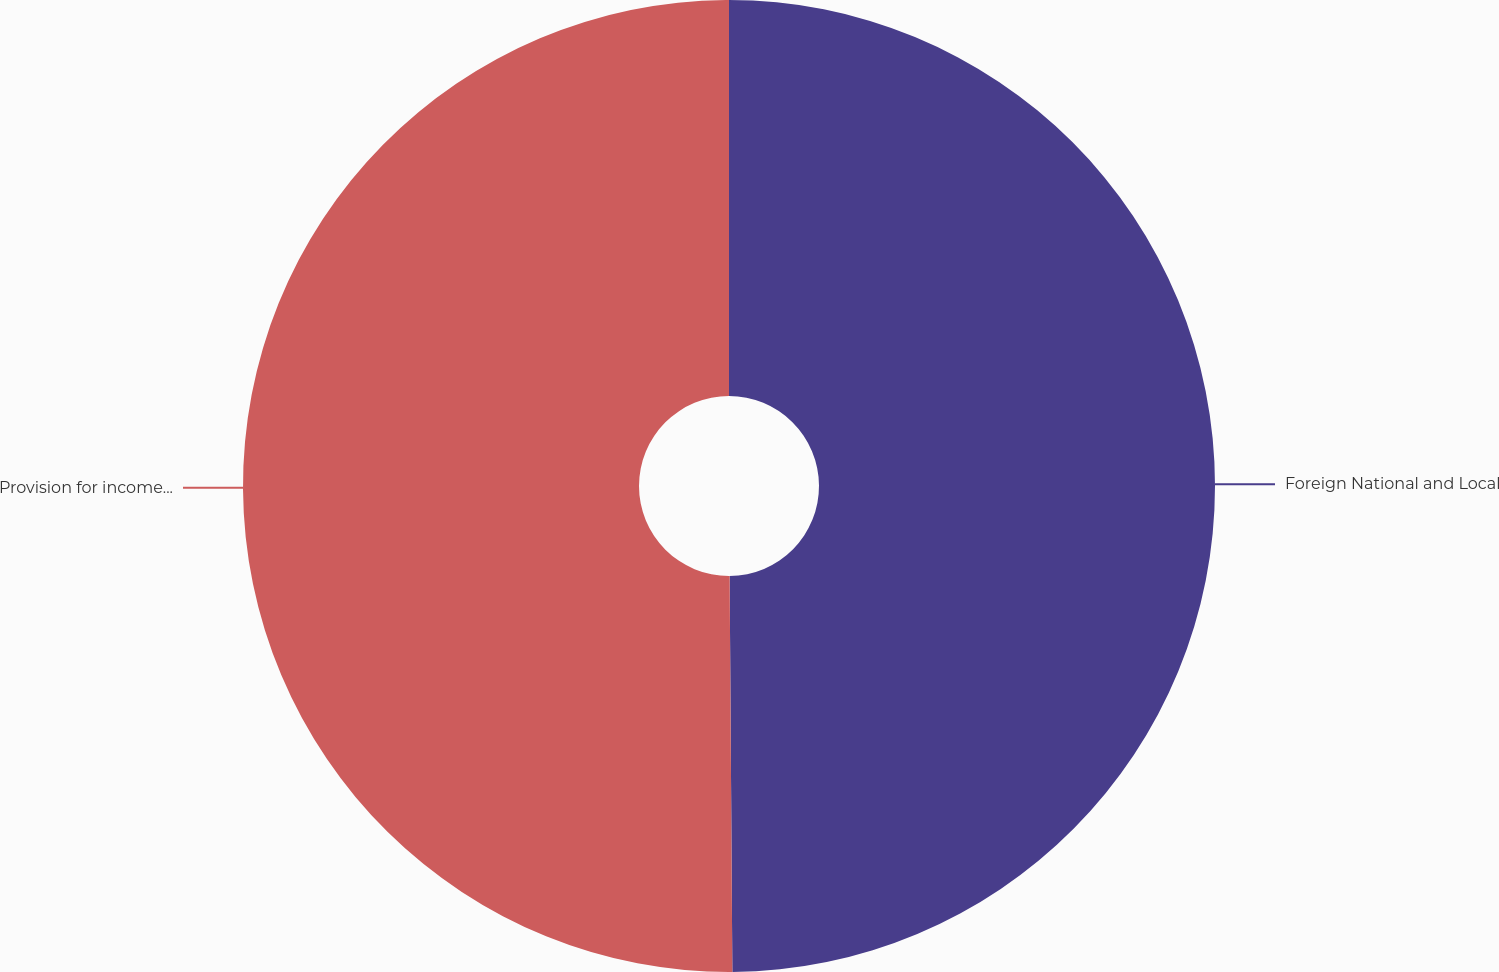Convert chart to OTSL. <chart><loc_0><loc_0><loc_500><loc_500><pie_chart><fcel>Foreign National and Local<fcel>Provision for income taxes<nl><fcel>49.89%<fcel>50.11%<nl></chart> 